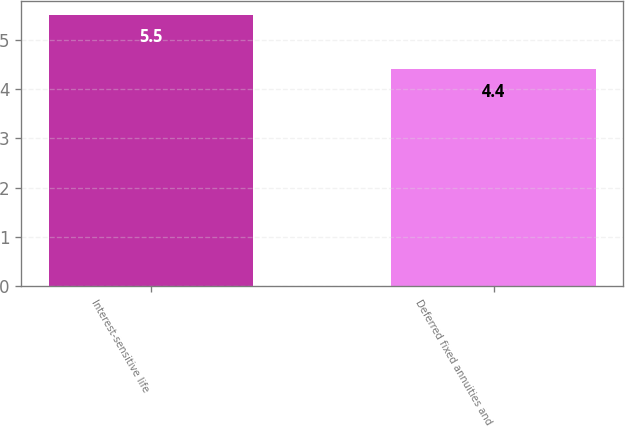Convert chart to OTSL. <chart><loc_0><loc_0><loc_500><loc_500><bar_chart><fcel>Interest-sensitive life<fcel>Deferred fixed annuities and<nl><fcel>5.5<fcel>4.4<nl></chart> 